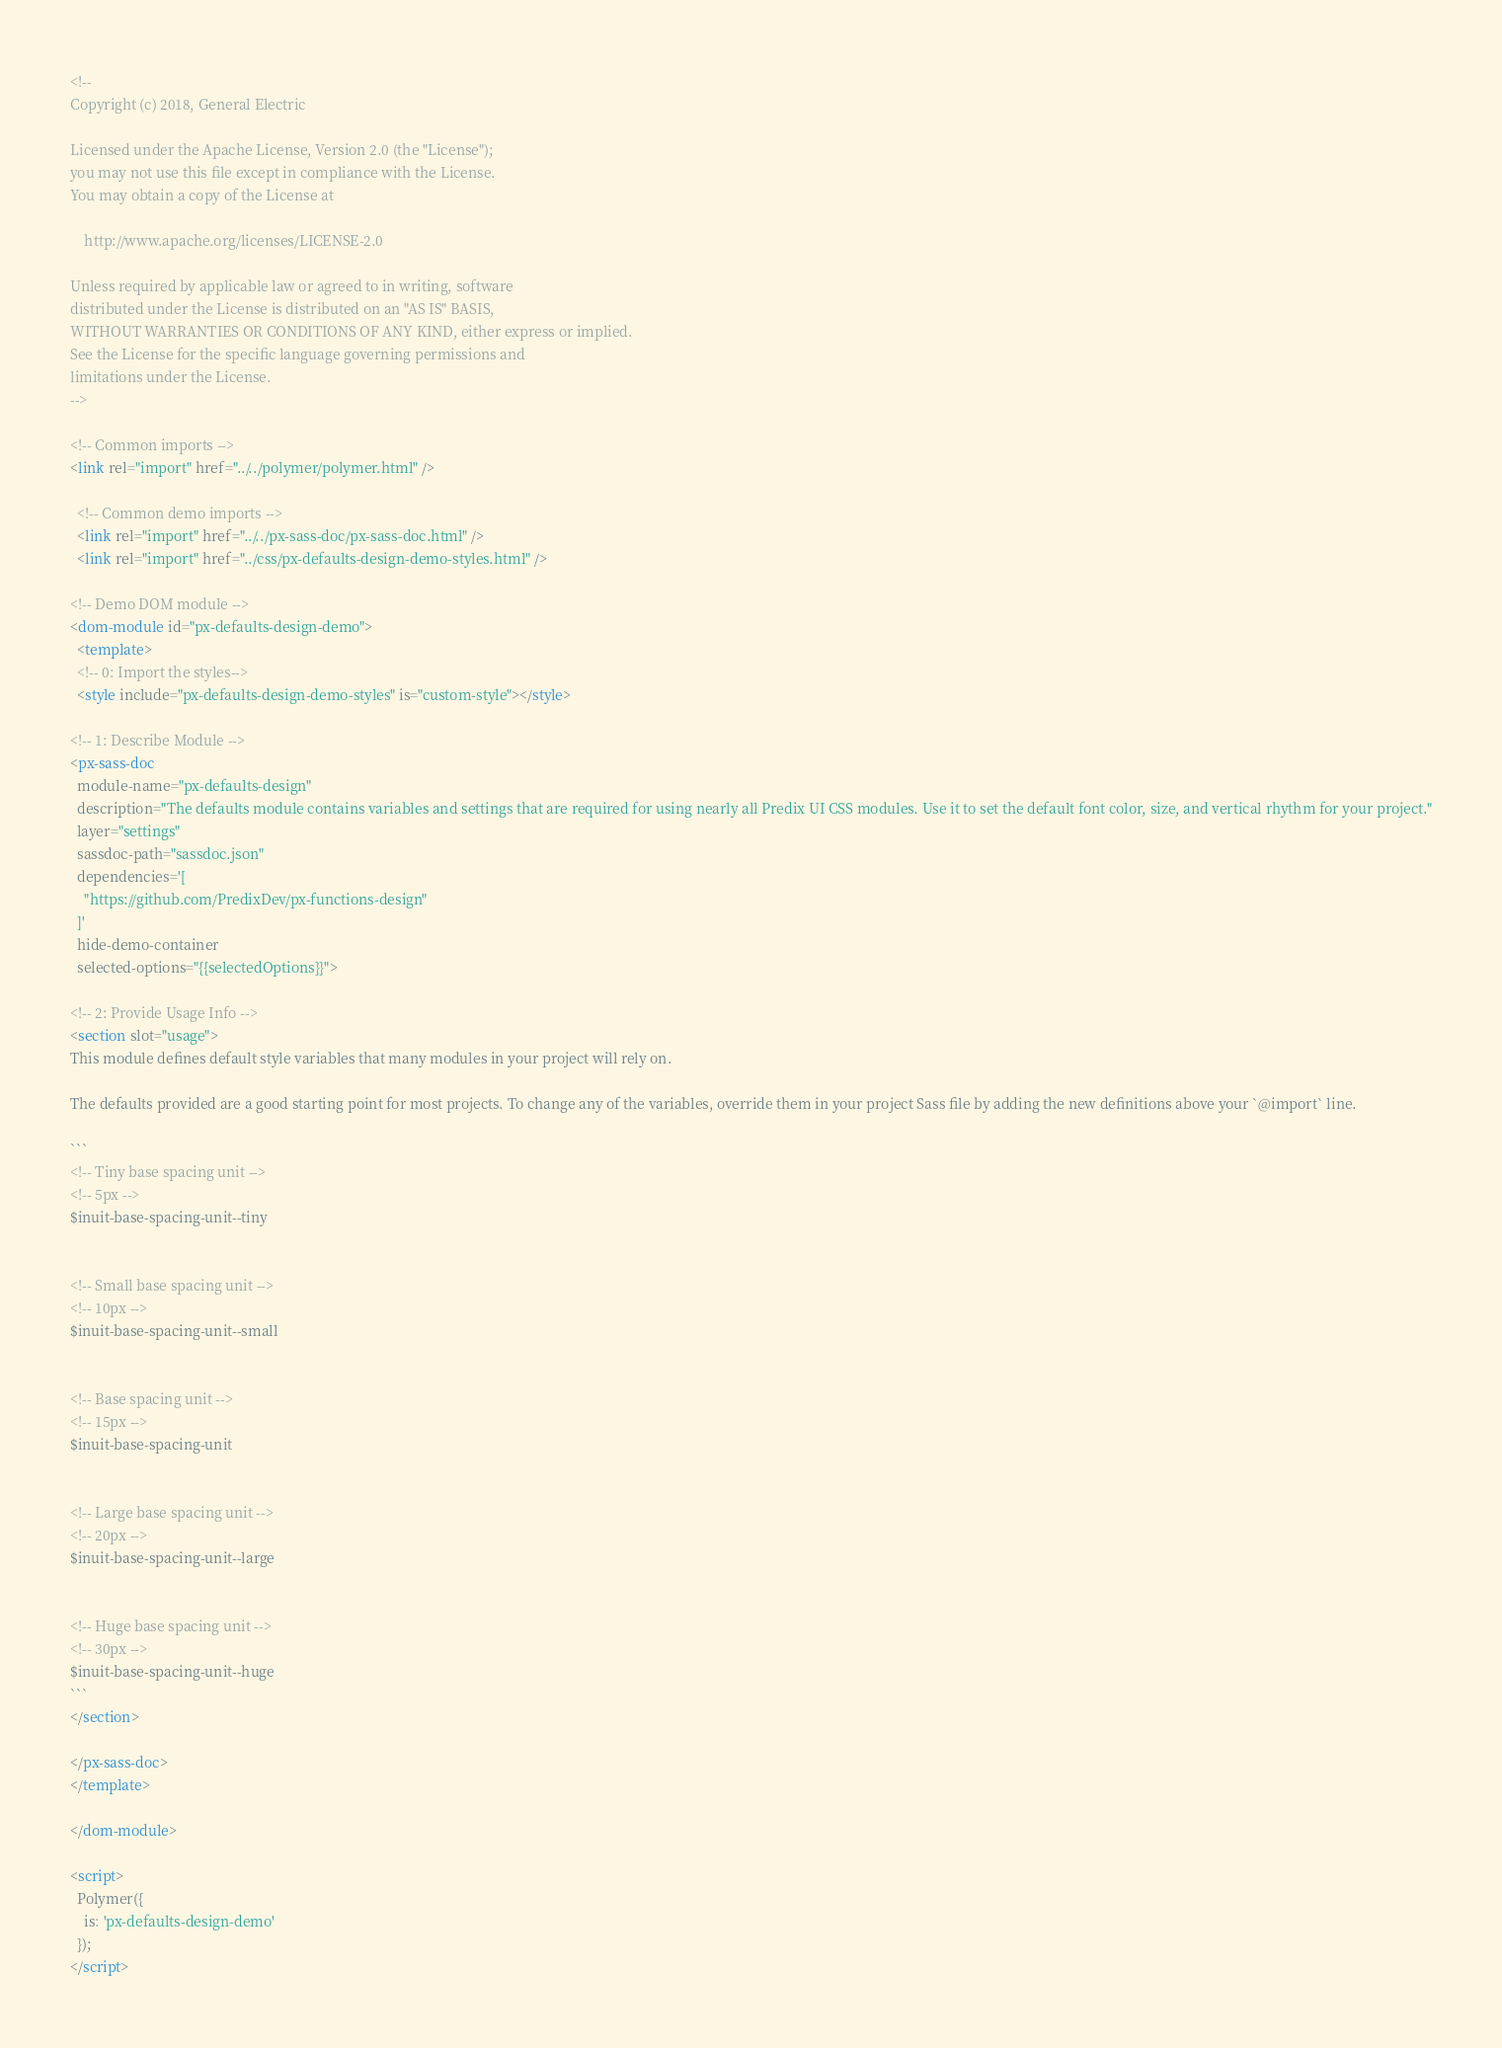Convert code to text. <code><loc_0><loc_0><loc_500><loc_500><_HTML_><!--
Copyright (c) 2018, General Electric

Licensed under the Apache License, Version 2.0 (the "License");
you may not use this file except in compliance with the License.
You may obtain a copy of the License at

    http://www.apache.org/licenses/LICENSE-2.0

Unless required by applicable law or agreed to in writing, software
distributed under the License is distributed on an "AS IS" BASIS,
WITHOUT WARRANTIES OR CONDITIONS OF ANY KIND, either express or implied.
See the License for the specific language governing permissions and
limitations under the License.
-->

<!-- Common imports -->
<link rel="import" href="../../polymer/polymer.html" />

  <!-- Common demo imports -->
  <link rel="import" href="../../px-sass-doc/px-sass-doc.html" />
  <link rel="import" href="../css/px-defaults-design-demo-styles.html" />

<!-- Demo DOM module -->
<dom-module id="px-defaults-design-demo">
  <template>
  <!-- 0: Import the styles-->
  <style include="px-defaults-design-demo-styles" is="custom-style"></style>

<!-- 1: Describe Module -->
<px-sass-doc
  module-name="px-defaults-design"
  description="The defaults module contains variables and settings that are required for using nearly all Predix UI CSS modules. Use it to set the default font color, size, and vertical rhythm for your project."
  layer="settings"
  sassdoc-path="sassdoc.json"
  dependencies='[
    "https://github.com/PredixDev/px-functions-design"
  ]'
  hide-demo-container
  selected-options="{{selectedOptions}}">

<!-- 2: Provide Usage Info -->
<section slot="usage">
This module defines default style variables that many modules in your project will rely on.

The defaults provided are a good starting point for most projects. To change any of the variables, override them in your project Sass file by adding the new definitions above your `@import` line.

```
<!-- Tiny base spacing unit -->
<!-- 5px -->
$inuit-base-spacing-unit--tiny


<!-- Small base spacing unit -->
<!-- 10px -->
$inuit-base-spacing-unit--small


<!-- Base spacing unit -->
<!-- 15px -->
$inuit-base-spacing-unit


<!-- Large base spacing unit -->
<!-- 20px -->
$inuit-base-spacing-unit--large


<!-- Huge base spacing unit -->
<!-- 30px -->
$inuit-base-spacing-unit--huge
```
</section>

</px-sass-doc>
</template>

</dom-module>

<script>
  Polymer({
    is: 'px-defaults-design-demo'
  });
</script>
</code> 